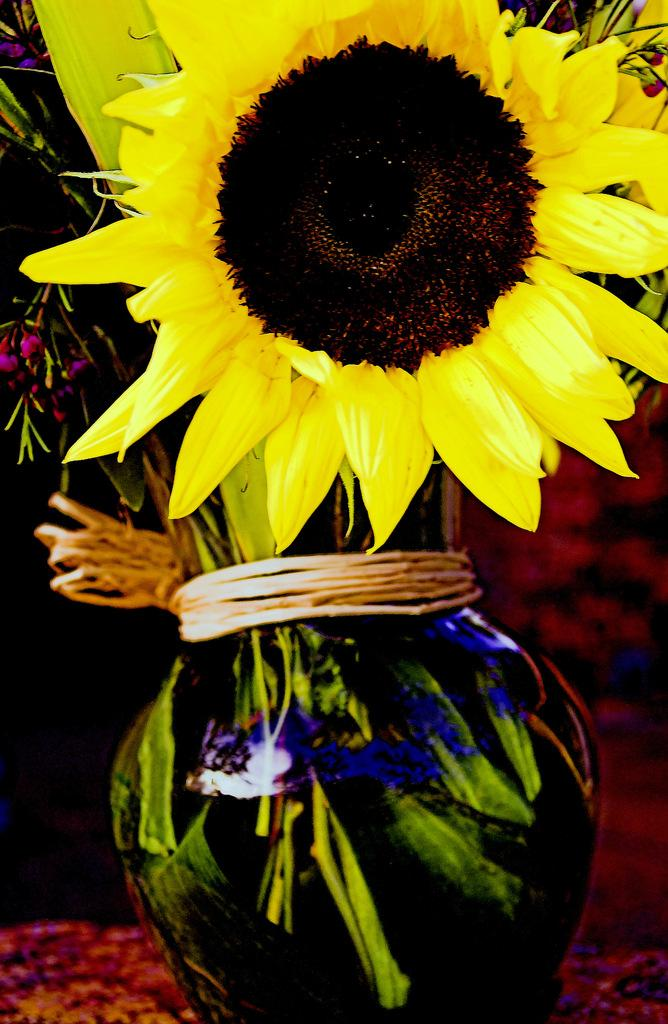What object is in the image that holds flowers and leaves? There is a vase in the image that contains flowers and leaves. What is inside the vase? The vase contains flowers and leaves. How would you describe the background of the image? The background of the image is blurry. Are there any other objects visible in the image besides the vase? Yes, there are objects visible in the background of the image. How many weeks does the expert take to play chess in the image? There is no expert playing chess in the image, nor is there any reference to time or chess. 